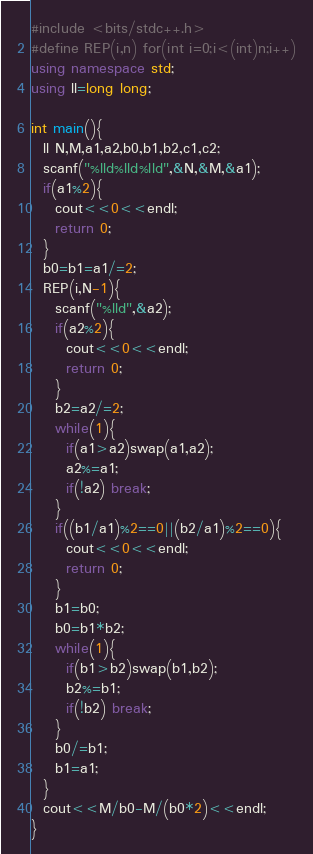Convert code to text. <code><loc_0><loc_0><loc_500><loc_500><_C++_>#include <bits/stdc++.h>
#define REP(i,n) for(int i=0;i<(int)n;i++)
using namespace std;
using ll=long long;

int main(){
  ll N,M,a1,a2,b0,b1,b2,c1,c2;
  scanf("%lld%lld%lld",&N,&M,&a1);
  if(a1%2){
    cout<<0<<endl;
    return 0;
  }
  b0=b1=a1/=2;
  REP(i,N-1){
    scanf("%lld",&a2);
    if(a2%2){
      cout<<0<<endl;
      return 0;
    }
    b2=a2/=2;
    while(1){
      if(a1>a2)swap(a1,a2);
      a2%=a1;
      if(!a2) break;
    }
    if((b1/a1)%2==0||(b2/a1)%2==0){
      cout<<0<<endl;
      return 0;
    }
    b1=b0;
    b0=b1*b2;
    while(1){
      if(b1>b2)swap(b1,b2);
      b2%=b1;
      if(!b2) break;
    }
    b0/=b1;
    b1=a1;
  }
  cout<<M/b0-M/(b0*2)<<endl;
}</code> 